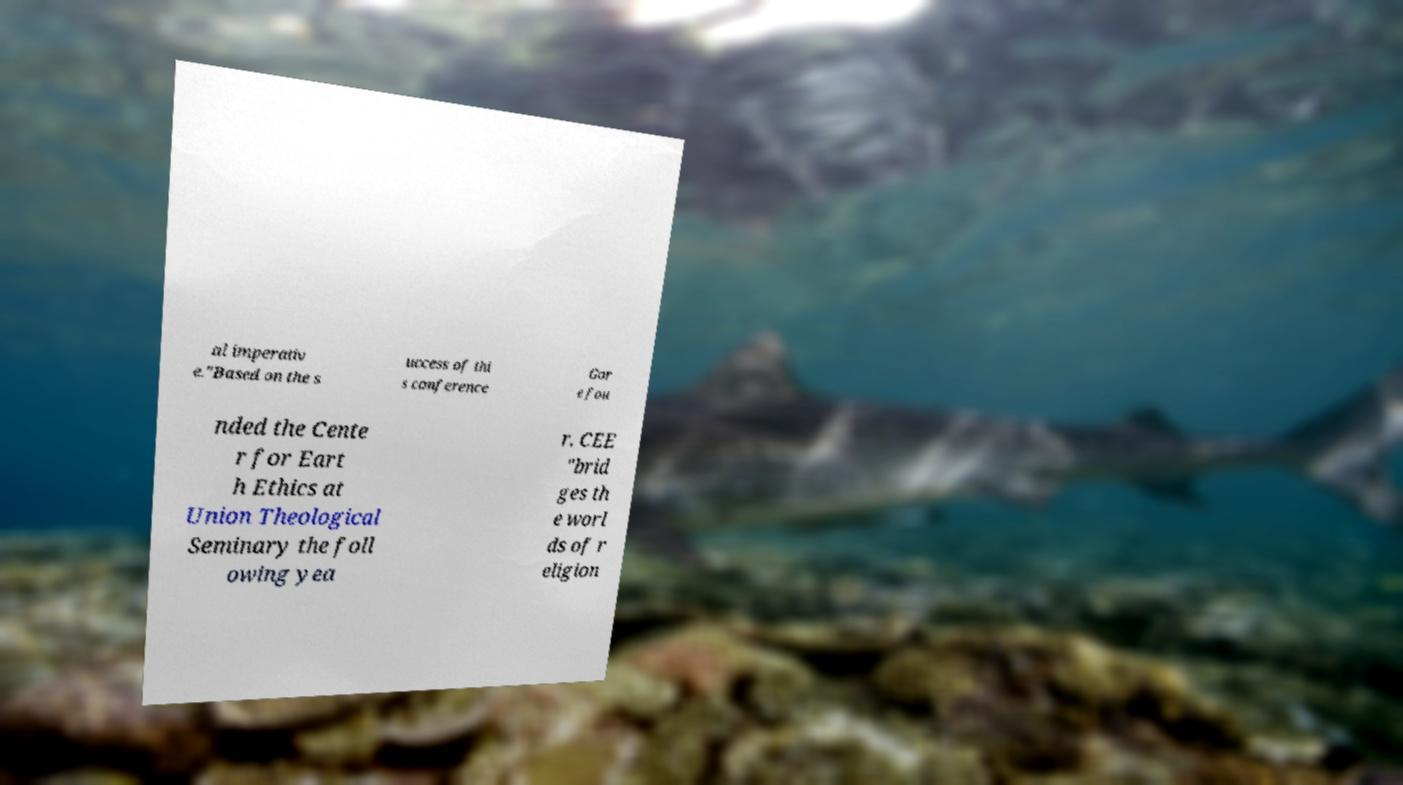I need the written content from this picture converted into text. Can you do that? al imperativ e."Based on the s uccess of thi s conference Gor e fou nded the Cente r for Eart h Ethics at Union Theological Seminary the foll owing yea r. CEE "brid ges th e worl ds of r eligion 